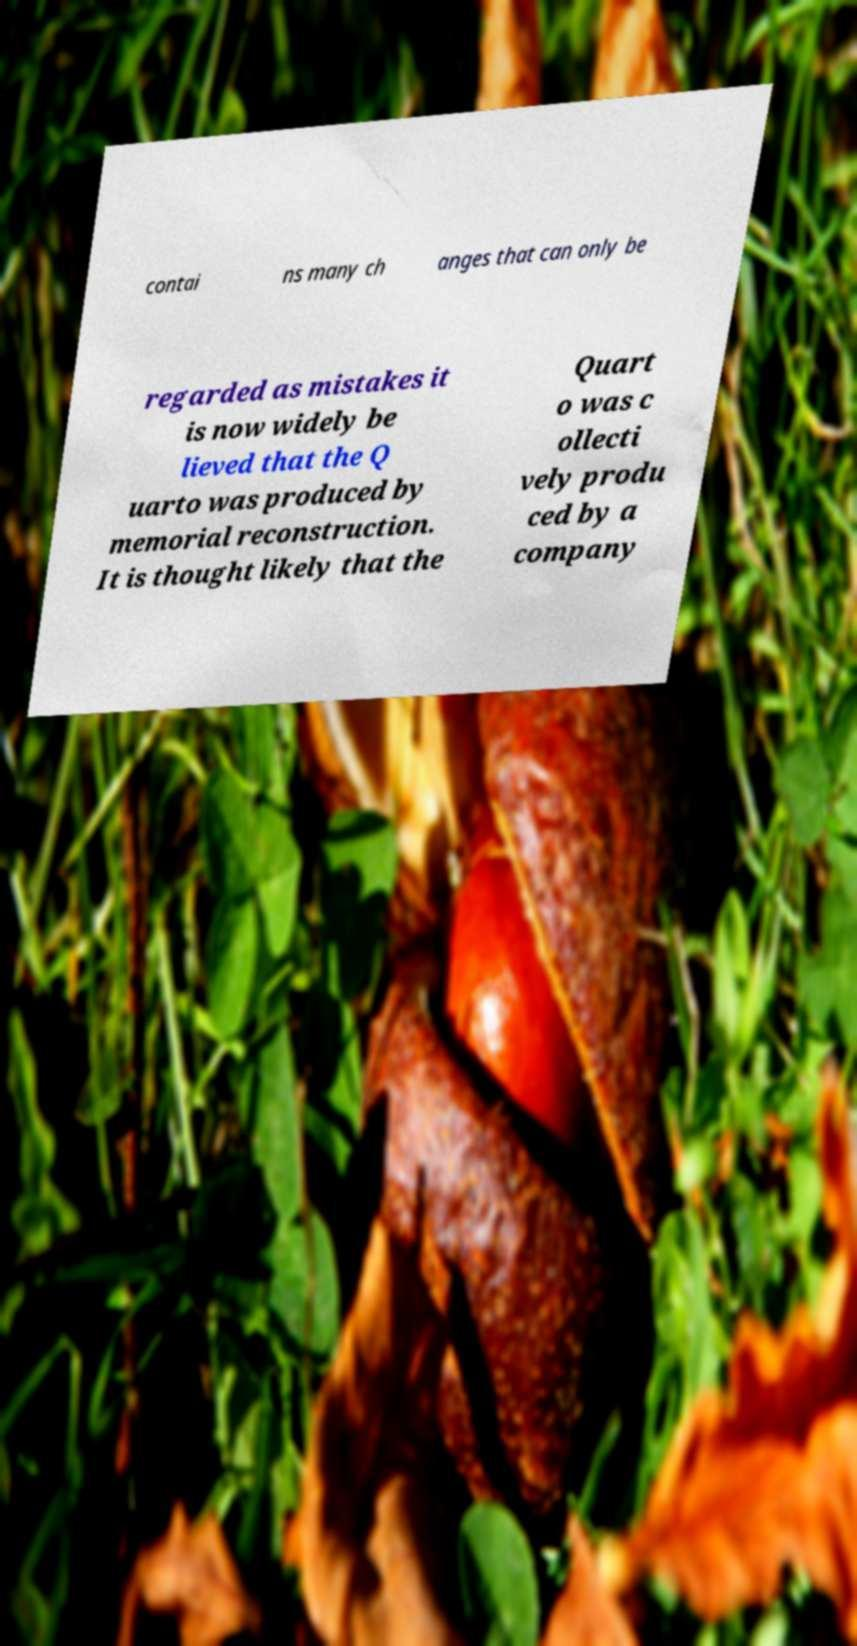For documentation purposes, I need the text within this image transcribed. Could you provide that? contai ns many ch anges that can only be regarded as mistakes it is now widely be lieved that the Q uarto was produced by memorial reconstruction. It is thought likely that the Quart o was c ollecti vely produ ced by a company 